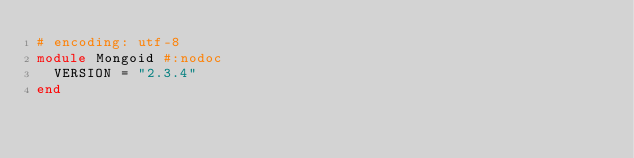<code> <loc_0><loc_0><loc_500><loc_500><_Ruby_># encoding: utf-8
module Mongoid #:nodoc
  VERSION = "2.3.4"
end
</code> 